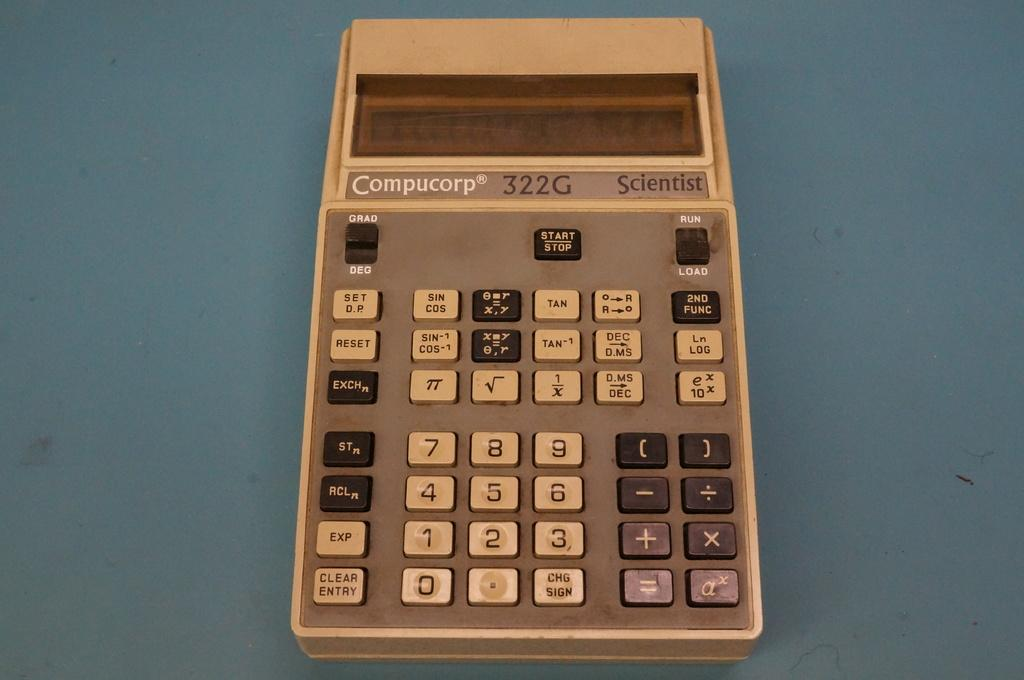<image>
Offer a succinct explanation of the picture presented. An ancient Compucorp 332G calculator, beige and with the basic buttons calculators had twenty years ago. 